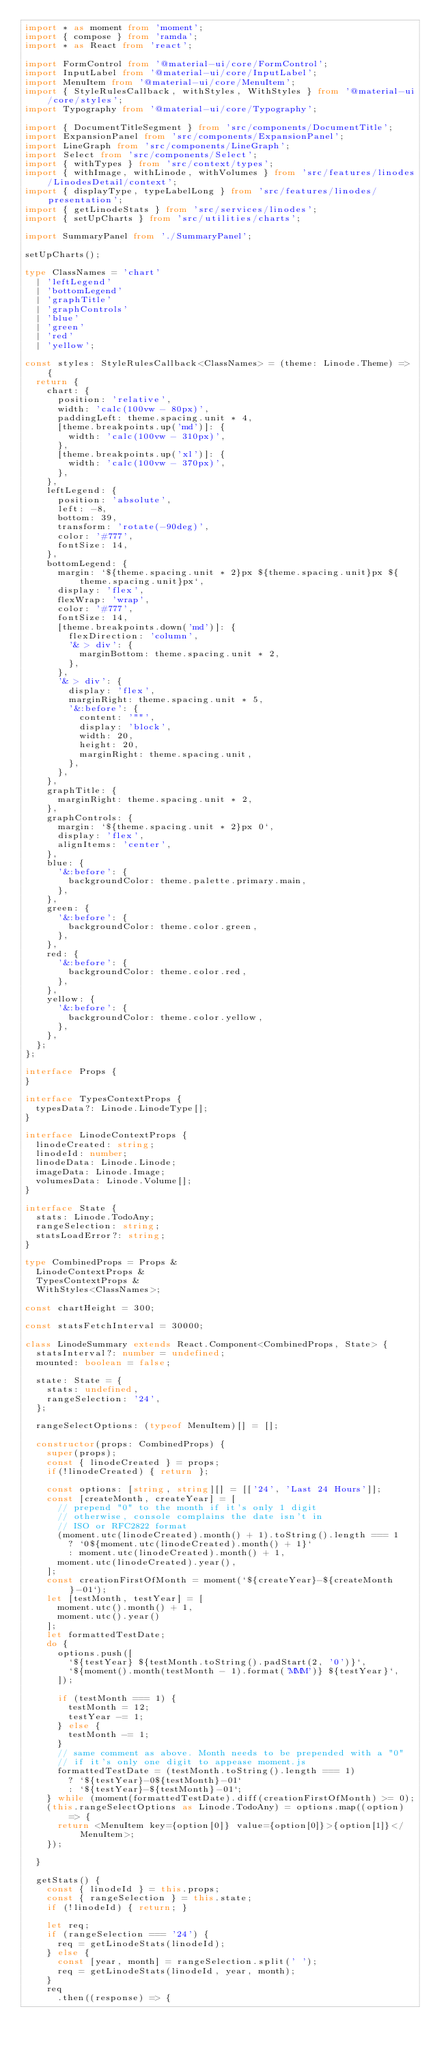Convert code to text. <code><loc_0><loc_0><loc_500><loc_500><_TypeScript_>import * as moment from 'moment';
import { compose } from 'ramda';
import * as React from 'react';

import FormControl from '@material-ui/core/FormControl';
import InputLabel from '@material-ui/core/InputLabel';
import MenuItem from '@material-ui/core/MenuItem';
import { StyleRulesCallback, withStyles, WithStyles } from '@material-ui/core/styles';
import Typography from '@material-ui/core/Typography';

import { DocumentTitleSegment } from 'src/components/DocumentTitle';
import ExpansionPanel from 'src/components/ExpansionPanel';
import LineGraph from 'src/components/LineGraph';
import Select from 'src/components/Select';
import { withTypes } from 'src/context/types';
import { withImage, withLinode, withVolumes } from 'src/features/linodes/LinodesDetail/context';
import { displayType, typeLabelLong } from 'src/features/linodes/presentation';
import { getLinodeStats } from 'src/services/linodes';
import { setUpCharts } from 'src/utilities/charts';

import SummaryPanel from './SummaryPanel';

setUpCharts();

type ClassNames = 'chart'
  | 'leftLegend'
  | 'bottomLegend'
  | 'graphTitle'
  | 'graphControls'
  | 'blue'
  | 'green'
  | 'red'
  | 'yellow';

const styles: StyleRulesCallback<ClassNames> = (theme: Linode.Theme) => {
  return {
    chart: {
      position: 'relative',
      width: 'calc(100vw - 80px)',
      paddingLeft: theme.spacing.unit * 4,
      [theme.breakpoints.up('md')]: {
        width: 'calc(100vw - 310px)',
      },
      [theme.breakpoints.up('xl')]: {
        width: 'calc(100vw - 370px)',
      },
    },
    leftLegend: {
      position: 'absolute',
      left: -8,
      bottom: 39,
      transform: 'rotate(-90deg)',
      color: '#777',
      fontSize: 14,
    },
    bottomLegend: {
      margin: `${theme.spacing.unit * 2}px ${theme.spacing.unit}px ${theme.spacing.unit}px`,
      display: 'flex',
      flexWrap: 'wrap',
      color: '#777',
      fontSize: 14,
      [theme.breakpoints.down('md')]: {
        flexDirection: 'column',
        '& > div': {
          marginBottom: theme.spacing.unit * 2,
        },
      },
      '& > div': {
        display: 'flex',
        marginRight: theme.spacing.unit * 5,
        '&:before': {
          content: '""',
          display: 'block',
          width: 20,
          height: 20,
          marginRight: theme.spacing.unit,
        },
      },
    },
    graphTitle: {
      marginRight: theme.spacing.unit * 2,
    },
    graphControls: {
      margin: `${theme.spacing.unit * 2}px 0`,
      display: 'flex',
      alignItems: 'center',
    },
    blue: {
      '&:before': {
        backgroundColor: theme.palette.primary.main,
      },
    },
    green: {
      '&:before': {
        backgroundColor: theme.color.green,
      },
    },
    red: {
      '&:before': {
        backgroundColor: theme.color.red,
      },
    },
    yellow: {
      '&:before': {
        backgroundColor: theme.color.yellow,
      },
    },
  };
};

interface Props {
}

interface TypesContextProps {
  typesData?: Linode.LinodeType[];
}

interface LinodeContextProps {
  linodeCreated: string;
  linodeId: number;
  linodeData: Linode.Linode;
  imageData: Linode.Image;
  volumesData: Linode.Volume[];
}

interface State {
  stats: Linode.TodoAny;
  rangeSelection: string;
  statsLoadError?: string;
}

type CombinedProps = Props &
  LinodeContextProps &
  TypesContextProps &
  WithStyles<ClassNames>;

const chartHeight = 300;

const statsFetchInterval = 30000;

class LinodeSummary extends React.Component<CombinedProps, State> {
  statsInterval?: number = undefined;
  mounted: boolean = false;

  state: State = {
    stats: undefined,
    rangeSelection: '24',
  };

  rangeSelectOptions: (typeof MenuItem)[] = [];

  constructor(props: CombinedProps) {
    super(props);
    const { linodeCreated } = props;
    if(!linodeCreated) { return };

    const options: [string, string][] = [['24', 'Last 24 Hours']];
    const [createMonth, createYear] = [
      // prepend "0" to the month if it's only 1 digit
      // otherwise, console complains the date isn't in
      // ISO or RFC2822 format
      (moment.utc(linodeCreated).month() + 1).toString().length === 1
        ? `0${moment.utc(linodeCreated).month() + 1}`
        : moment.utc(linodeCreated).month() + 1,
      moment.utc(linodeCreated).year(),
    ];
    const creationFirstOfMonth = moment(`${createYear}-${createMonth}-01`);
    let [testMonth, testYear] = [
      moment.utc().month() + 1,
      moment.utc().year()
    ];
    let formattedTestDate;
    do {
      options.push([
        `${testYear} ${testMonth.toString().padStart(2, '0')}`,
        `${moment().month(testMonth - 1).format('MMM')} ${testYear}`,
      ]);

      if (testMonth === 1) {
        testMonth = 12;
        testYear -= 1;
      } else {
        testMonth -= 1;
      }
      // same comment as above. Month needs to be prepended with a "0"
      // if it's only one digit to appease moment.js
      formattedTestDate = (testMonth.toString().length === 1)
        ? `${testYear}-0${testMonth}-01`
        : `${testYear}-${testMonth}-01`;
    } while (moment(formattedTestDate).diff(creationFirstOfMonth) >= 0);
    (this.rangeSelectOptions as Linode.TodoAny) = options.map((option) => {
      return <MenuItem key={option[0]} value={option[0]}>{option[1]}</MenuItem>;
    });

  }

  getStats() {
    const { linodeId } = this.props;
    const { rangeSelection } = this.state;
    if (!linodeId) { return; }

    let req;
    if (rangeSelection === '24') {
      req = getLinodeStats(linodeId);
    } else {
      const [year, month] = rangeSelection.split(' ');
      req = getLinodeStats(linodeId, year, month);
    }
    req
      .then((response) => {</code> 